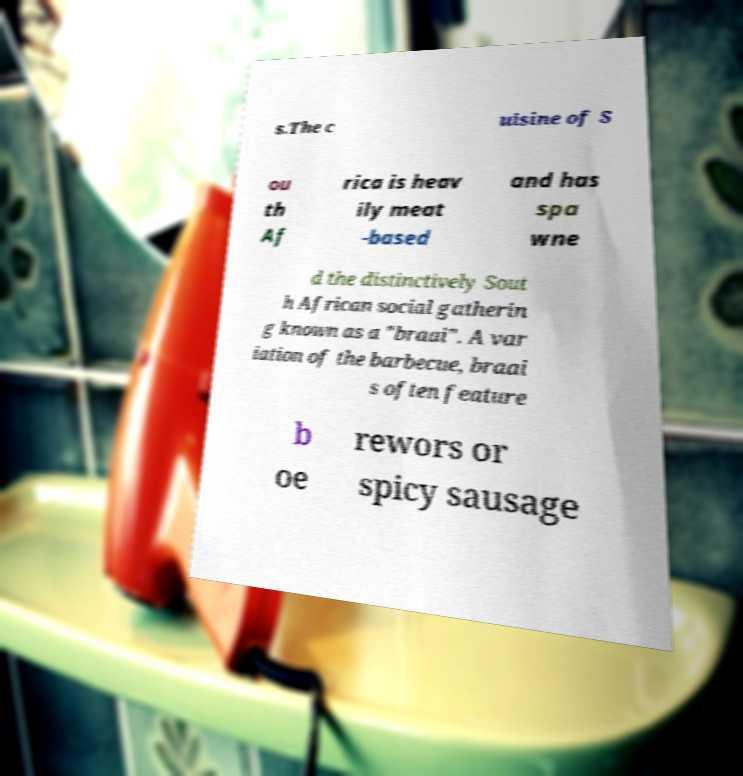I need the written content from this picture converted into text. Can you do that? s.The c uisine of S ou th Af rica is heav ily meat -based and has spa wne d the distinctively Sout h African social gatherin g known as a "braai". A var iation of the barbecue, braai s often feature b oe rewors or spicy sausage 